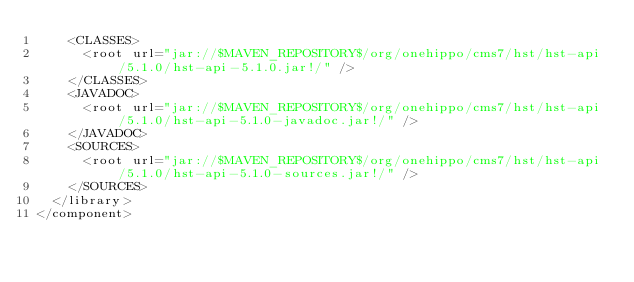Convert code to text. <code><loc_0><loc_0><loc_500><loc_500><_XML_>    <CLASSES>
      <root url="jar://$MAVEN_REPOSITORY$/org/onehippo/cms7/hst/hst-api/5.1.0/hst-api-5.1.0.jar!/" />
    </CLASSES>
    <JAVADOC>
      <root url="jar://$MAVEN_REPOSITORY$/org/onehippo/cms7/hst/hst-api/5.1.0/hst-api-5.1.0-javadoc.jar!/" />
    </JAVADOC>
    <SOURCES>
      <root url="jar://$MAVEN_REPOSITORY$/org/onehippo/cms7/hst/hst-api/5.1.0/hst-api-5.1.0-sources.jar!/" />
    </SOURCES>
  </library>
</component></code> 